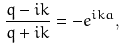<formula> <loc_0><loc_0><loc_500><loc_500>\frac { q - i k } { q + i k } = - e ^ { i k a } ,</formula> 